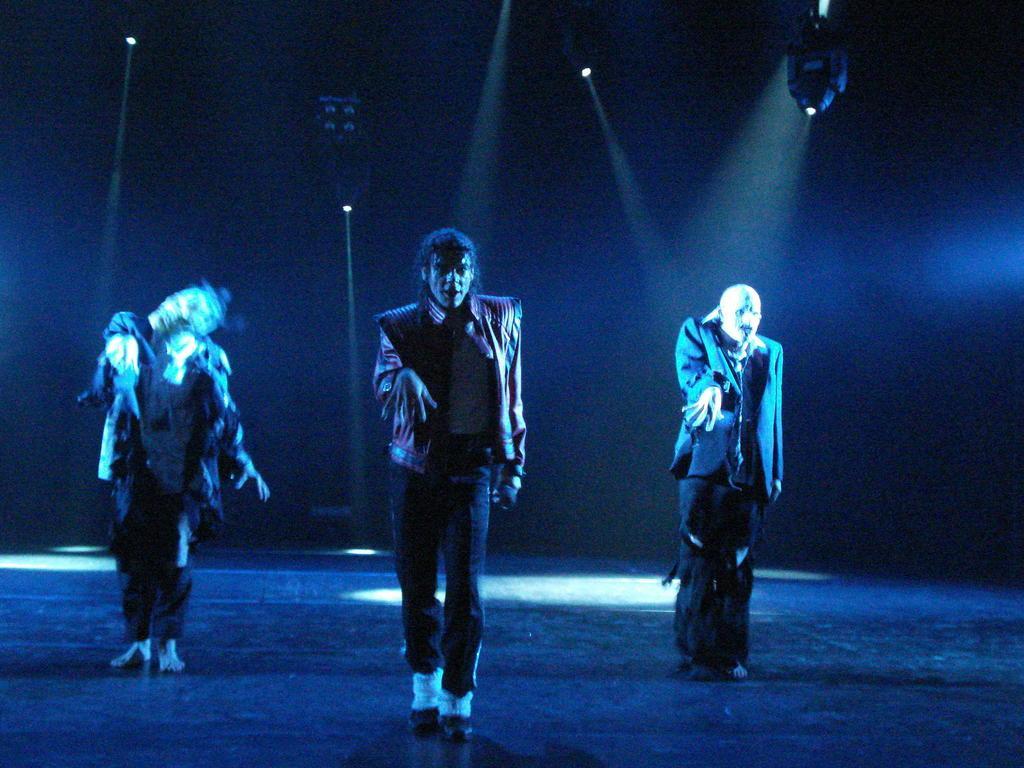How would you summarize this image in a sentence or two? In this image, there are a few people standing on the ground. We can see the dark background and some lights. We can also see an object at the top. 